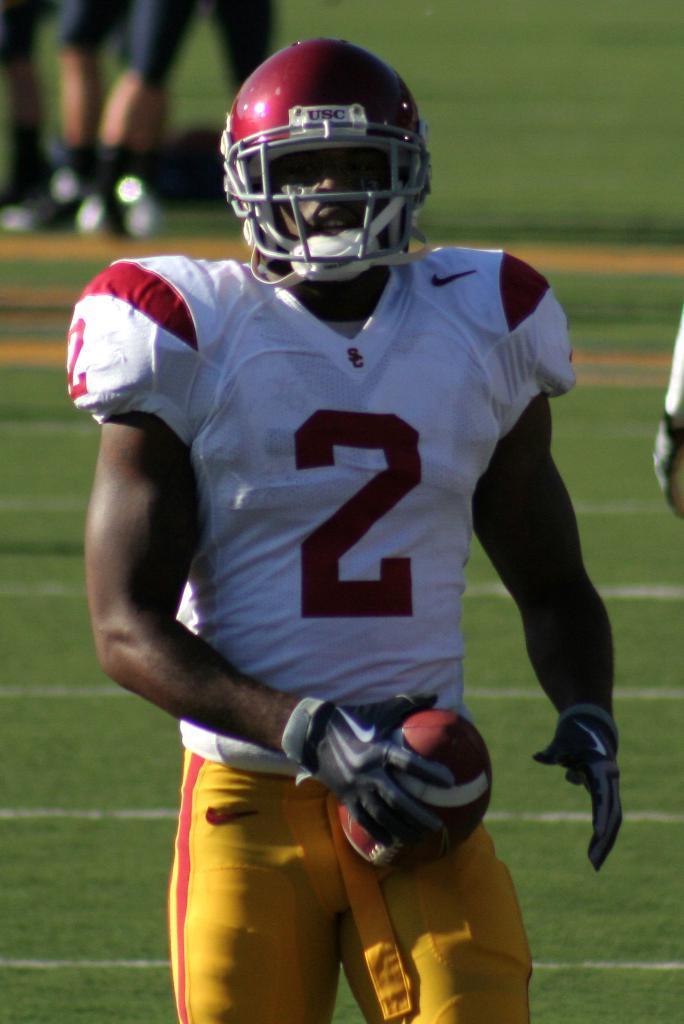How would you summarize this image in a sentence or two? In this picture we can see a man and he is holding a ball and in the background we can see the ground and legs of few people. 